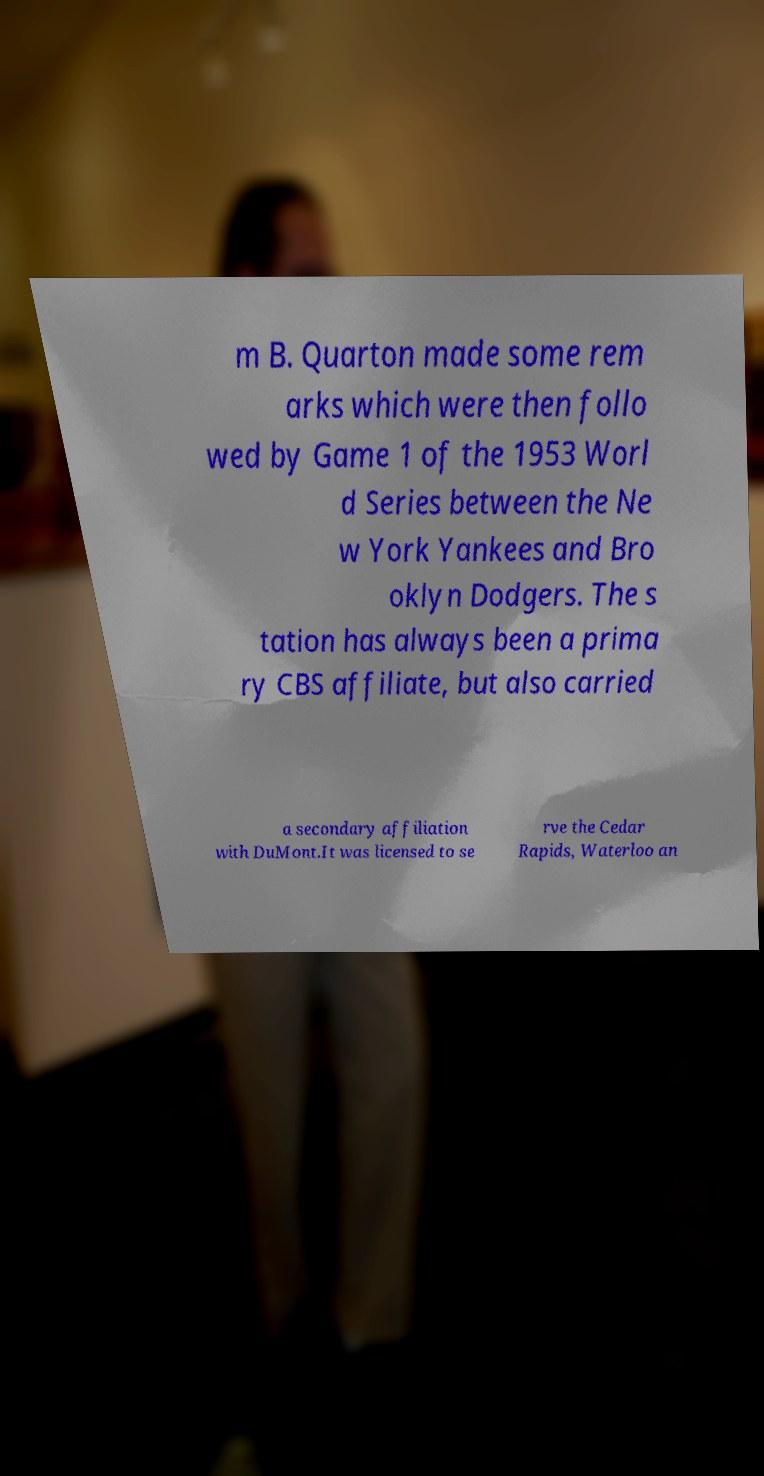I need the written content from this picture converted into text. Can you do that? m B. Quarton made some rem arks which were then follo wed by Game 1 of the 1953 Worl d Series between the Ne w York Yankees and Bro oklyn Dodgers. The s tation has always been a prima ry CBS affiliate, but also carried a secondary affiliation with DuMont.It was licensed to se rve the Cedar Rapids, Waterloo an 